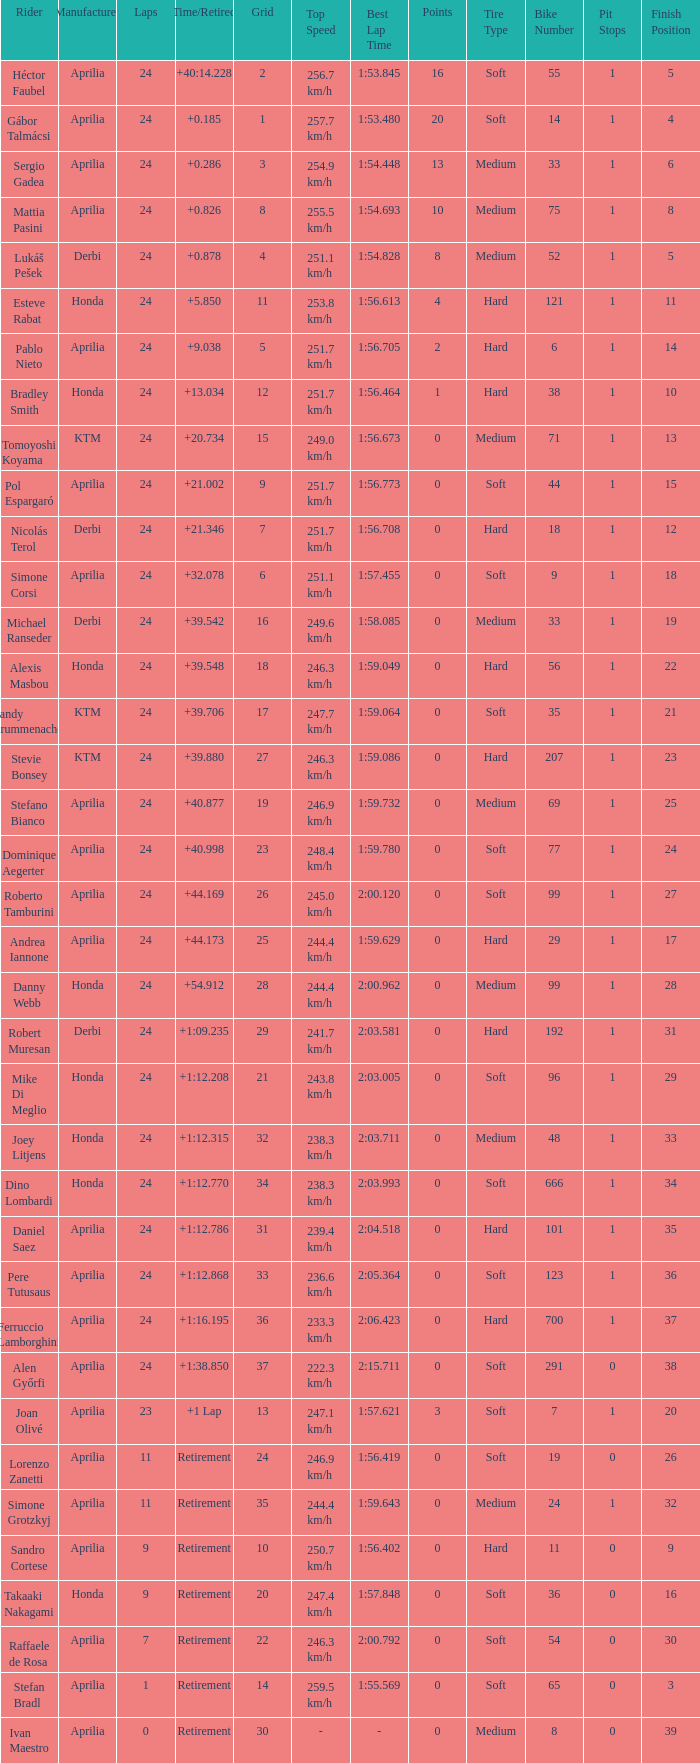How many grids correspond to more than 24 laps? None. 